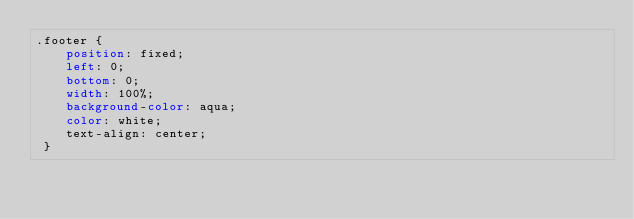<code> <loc_0><loc_0><loc_500><loc_500><_CSS_>.footer {
    position: fixed;
    left: 0;
    bottom: 0;
    width: 100%;
    background-color: aqua;
    color: white;
    text-align: center;
 }
</code> 